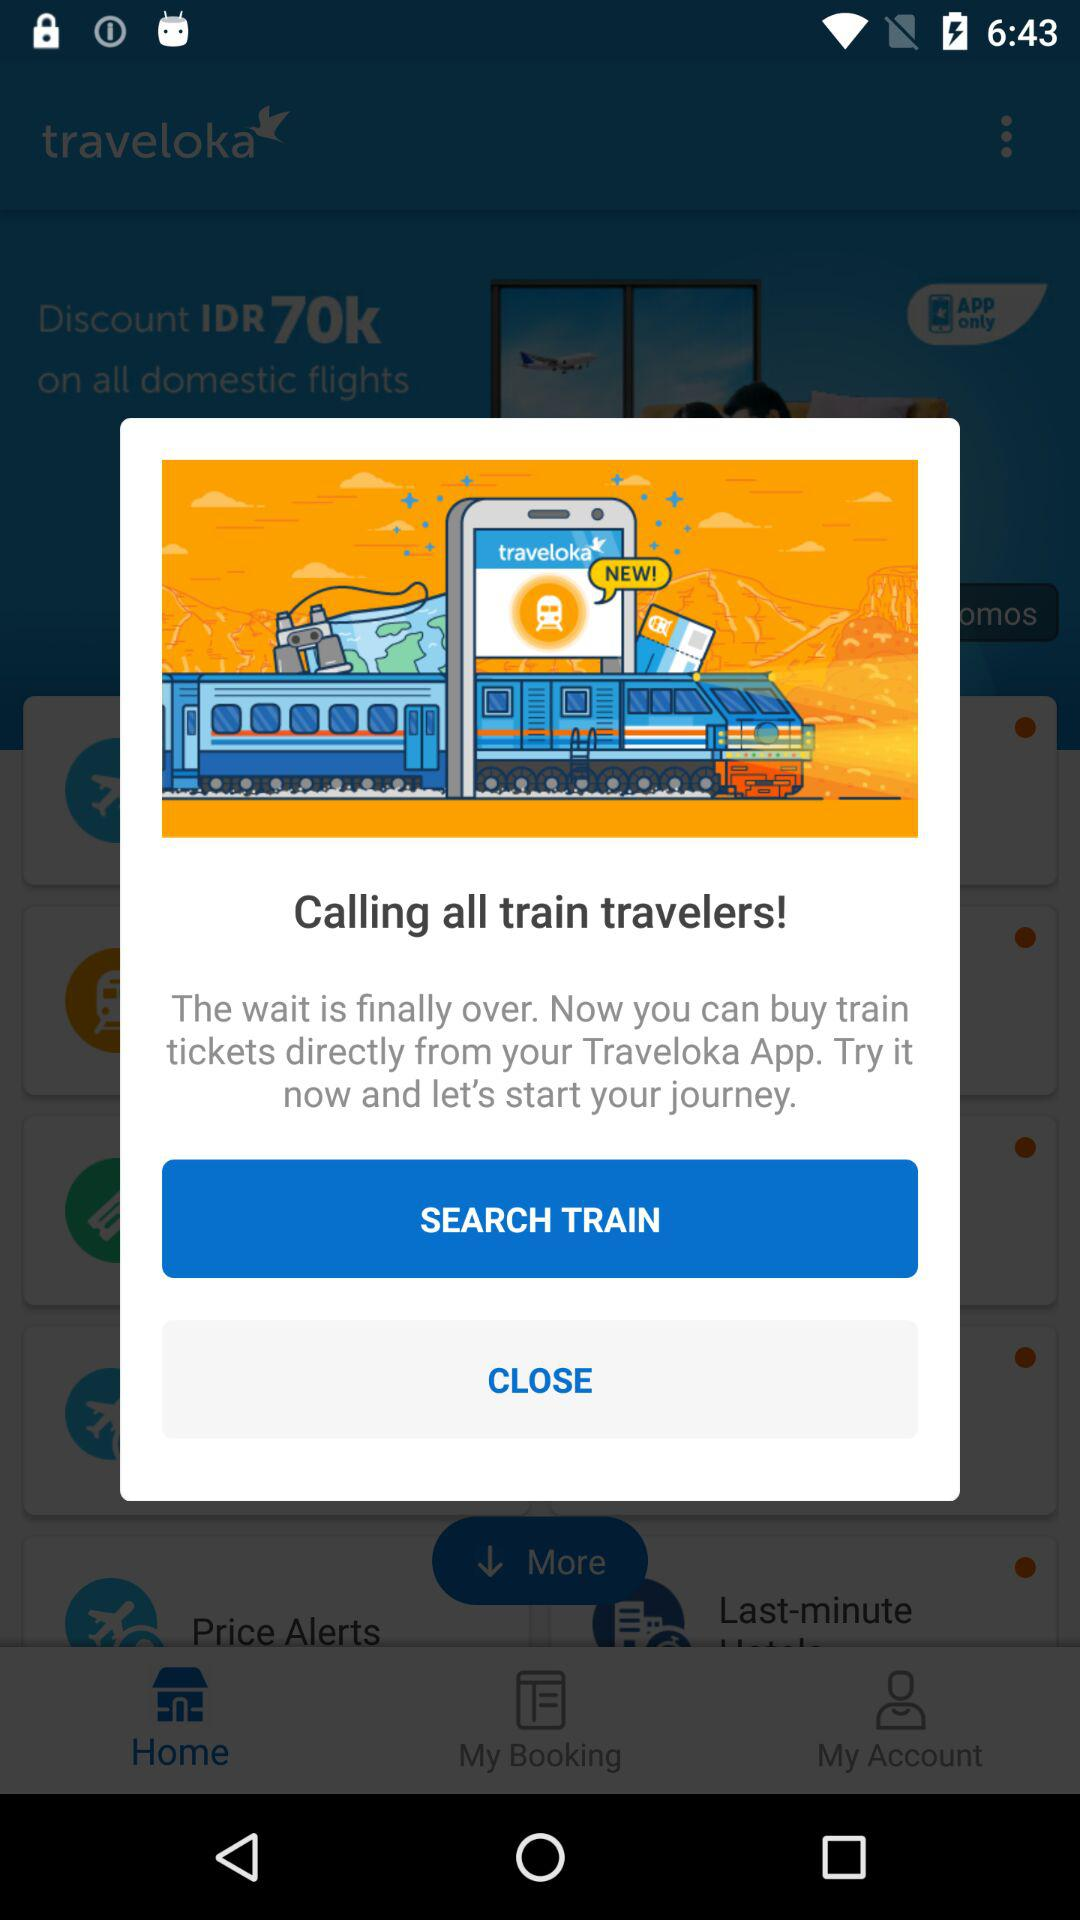Which version of "traveloka" is this?
When the provided information is insufficient, respond with <no answer>. <no answer> 